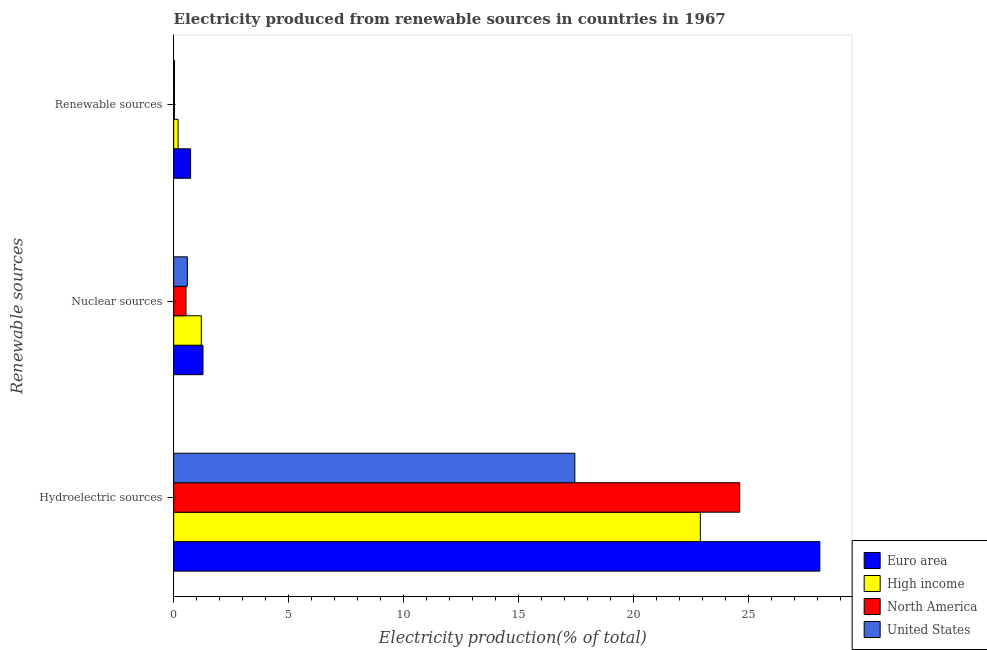How many different coloured bars are there?
Ensure brevity in your answer.  4. What is the label of the 1st group of bars from the top?
Keep it short and to the point. Renewable sources. What is the percentage of electricity produced by hydroelectric sources in High income?
Offer a terse response. 22.91. Across all countries, what is the maximum percentage of electricity produced by nuclear sources?
Provide a short and direct response. 1.27. Across all countries, what is the minimum percentage of electricity produced by hydroelectric sources?
Your answer should be compact. 17.45. In which country was the percentage of electricity produced by nuclear sources maximum?
Give a very brief answer. Euro area. In which country was the percentage of electricity produced by hydroelectric sources minimum?
Your answer should be compact. United States. What is the total percentage of electricity produced by hydroelectric sources in the graph?
Ensure brevity in your answer.  93.08. What is the difference between the percentage of electricity produced by renewable sources in Euro area and that in United States?
Your answer should be compact. 0.7. What is the difference between the percentage of electricity produced by nuclear sources in High income and the percentage of electricity produced by hydroelectric sources in North America?
Keep it short and to the point. -23.42. What is the average percentage of electricity produced by renewable sources per country?
Keep it short and to the point. 0.25. What is the difference between the percentage of electricity produced by hydroelectric sources and percentage of electricity produced by nuclear sources in North America?
Your response must be concise. 24.08. In how many countries, is the percentage of electricity produced by renewable sources greater than 1 %?
Provide a succinct answer. 0. What is the ratio of the percentage of electricity produced by renewable sources in High income to that in United States?
Provide a succinct answer. 5.17. Is the percentage of electricity produced by hydroelectric sources in United States less than that in High income?
Offer a very short reply. Yes. Is the difference between the percentage of electricity produced by renewable sources in North America and High income greater than the difference between the percentage of electricity produced by nuclear sources in North America and High income?
Ensure brevity in your answer.  Yes. What is the difference between the highest and the second highest percentage of electricity produced by nuclear sources?
Your answer should be very brief. 0.07. What is the difference between the highest and the lowest percentage of electricity produced by hydroelectric sources?
Your answer should be very brief. 10.66. In how many countries, is the percentage of electricity produced by nuclear sources greater than the average percentage of electricity produced by nuclear sources taken over all countries?
Give a very brief answer. 2. Is it the case that in every country, the sum of the percentage of electricity produced by hydroelectric sources and percentage of electricity produced by nuclear sources is greater than the percentage of electricity produced by renewable sources?
Your answer should be compact. Yes. How many bars are there?
Make the answer very short. 12. How many countries are there in the graph?
Offer a very short reply. 4. Are the values on the major ticks of X-axis written in scientific E-notation?
Provide a succinct answer. No. Does the graph contain any zero values?
Provide a short and direct response. No. How are the legend labels stacked?
Offer a very short reply. Vertical. What is the title of the graph?
Give a very brief answer. Electricity produced from renewable sources in countries in 1967. What is the label or title of the Y-axis?
Offer a terse response. Renewable sources. What is the Electricity production(% of total) of Euro area in Hydroelectric sources?
Your answer should be compact. 28.1. What is the Electricity production(% of total) in High income in Hydroelectric sources?
Your response must be concise. 22.91. What is the Electricity production(% of total) in North America in Hydroelectric sources?
Provide a succinct answer. 24.62. What is the Electricity production(% of total) in United States in Hydroelectric sources?
Offer a very short reply. 17.45. What is the Electricity production(% of total) in Euro area in Nuclear sources?
Your response must be concise. 1.27. What is the Electricity production(% of total) in High income in Nuclear sources?
Your answer should be compact. 1.2. What is the Electricity production(% of total) of North America in Nuclear sources?
Your response must be concise. 0.54. What is the Electricity production(% of total) of United States in Nuclear sources?
Your response must be concise. 0.59. What is the Electricity production(% of total) of Euro area in Renewable sources?
Your answer should be compact. 0.74. What is the Electricity production(% of total) in High income in Renewable sources?
Your response must be concise. 0.19. What is the Electricity production(% of total) in North America in Renewable sources?
Offer a very short reply. 0.03. What is the Electricity production(% of total) in United States in Renewable sources?
Provide a short and direct response. 0.04. Across all Renewable sources, what is the maximum Electricity production(% of total) in Euro area?
Provide a succinct answer. 28.1. Across all Renewable sources, what is the maximum Electricity production(% of total) of High income?
Provide a short and direct response. 22.91. Across all Renewable sources, what is the maximum Electricity production(% of total) in North America?
Your response must be concise. 24.62. Across all Renewable sources, what is the maximum Electricity production(% of total) of United States?
Give a very brief answer. 17.45. Across all Renewable sources, what is the minimum Electricity production(% of total) in Euro area?
Offer a very short reply. 0.74. Across all Renewable sources, what is the minimum Electricity production(% of total) of High income?
Give a very brief answer. 0.19. Across all Renewable sources, what is the minimum Electricity production(% of total) in North America?
Your answer should be very brief. 0.03. Across all Renewable sources, what is the minimum Electricity production(% of total) in United States?
Your answer should be very brief. 0.04. What is the total Electricity production(% of total) in Euro area in the graph?
Provide a short and direct response. 30.11. What is the total Electricity production(% of total) of High income in the graph?
Make the answer very short. 24.3. What is the total Electricity production(% of total) in North America in the graph?
Ensure brevity in your answer.  25.19. What is the total Electricity production(% of total) in United States in the graph?
Provide a succinct answer. 18.08. What is the difference between the Electricity production(% of total) of Euro area in Hydroelectric sources and that in Nuclear sources?
Make the answer very short. 26.83. What is the difference between the Electricity production(% of total) in High income in Hydroelectric sources and that in Nuclear sources?
Make the answer very short. 21.71. What is the difference between the Electricity production(% of total) in North America in Hydroelectric sources and that in Nuclear sources?
Provide a short and direct response. 24.08. What is the difference between the Electricity production(% of total) in United States in Hydroelectric sources and that in Nuclear sources?
Your answer should be compact. 16.85. What is the difference between the Electricity production(% of total) of Euro area in Hydroelectric sources and that in Renewable sources?
Keep it short and to the point. 27.37. What is the difference between the Electricity production(% of total) of High income in Hydroelectric sources and that in Renewable sources?
Give a very brief answer. 22.72. What is the difference between the Electricity production(% of total) in North America in Hydroelectric sources and that in Renewable sources?
Offer a terse response. 24.59. What is the difference between the Electricity production(% of total) of United States in Hydroelectric sources and that in Renewable sources?
Give a very brief answer. 17.41. What is the difference between the Electricity production(% of total) in Euro area in Nuclear sources and that in Renewable sources?
Provide a succinct answer. 0.54. What is the difference between the Electricity production(% of total) of High income in Nuclear sources and that in Renewable sources?
Offer a very short reply. 1.01. What is the difference between the Electricity production(% of total) in North America in Nuclear sources and that in Renewable sources?
Ensure brevity in your answer.  0.5. What is the difference between the Electricity production(% of total) of United States in Nuclear sources and that in Renewable sources?
Keep it short and to the point. 0.56. What is the difference between the Electricity production(% of total) of Euro area in Hydroelectric sources and the Electricity production(% of total) of High income in Nuclear sources?
Your answer should be very brief. 26.9. What is the difference between the Electricity production(% of total) in Euro area in Hydroelectric sources and the Electricity production(% of total) in North America in Nuclear sources?
Keep it short and to the point. 27.57. What is the difference between the Electricity production(% of total) in Euro area in Hydroelectric sources and the Electricity production(% of total) in United States in Nuclear sources?
Make the answer very short. 27.51. What is the difference between the Electricity production(% of total) of High income in Hydroelectric sources and the Electricity production(% of total) of North America in Nuclear sources?
Keep it short and to the point. 22.37. What is the difference between the Electricity production(% of total) in High income in Hydroelectric sources and the Electricity production(% of total) in United States in Nuclear sources?
Make the answer very short. 22.31. What is the difference between the Electricity production(% of total) in North America in Hydroelectric sources and the Electricity production(% of total) in United States in Nuclear sources?
Keep it short and to the point. 24.02. What is the difference between the Electricity production(% of total) of Euro area in Hydroelectric sources and the Electricity production(% of total) of High income in Renewable sources?
Your answer should be very brief. 27.91. What is the difference between the Electricity production(% of total) in Euro area in Hydroelectric sources and the Electricity production(% of total) in North America in Renewable sources?
Give a very brief answer. 28.07. What is the difference between the Electricity production(% of total) of Euro area in Hydroelectric sources and the Electricity production(% of total) of United States in Renewable sources?
Provide a short and direct response. 28.07. What is the difference between the Electricity production(% of total) in High income in Hydroelectric sources and the Electricity production(% of total) in North America in Renewable sources?
Keep it short and to the point. 22.87. What is the difference between the Electricity production(% of total) in High income in Hydroelectric sources and the Electricity production(% of total) in United States in Renewable sources?
Offer a terse response. 22.87. What is the difference between the Electricity production(% of total) of North America in Hydroelectric sources and the Electricity production(% of total) of United States in Renewable sources?
Provide a succinct answer. 24.58. What is the difference between the Electricity production(% of total) of Euro area in Nuclear sources and the Electricity production(% of total) of High income in Renewable sources?
Give a very brief answer. 1.08. What is the difference between the Electricity production(% of total) of Euro area in Nuclear sources and the Electricity production(% of total) of North America in Renewable sources?
Provide a succinct answer. 1.24. What is the difference between the Electricity production(% of total) in Euro area in Nuclear sources and the Electricity production(% of total) in United States in Renewable sources?
Give a very brief answer. 1.24. What is the difference between the Electricity production(% of total) of High income in Nuclear sources and the Electricity production(% of total) of North America in Renewable sources?
Make the answer very short. 1.17. What is the difference between the Electricity production(% of total) of High income in Nuclear sources and the Electricity production(% of total) of United States in Renewable sources?
Your answer should be very brief. 1.16. What is the difference between the Electricity production(% of total) in North America in Nuclear sources and the Electricity production(% of total) in United States in Renewable sources?
Offer a terse response. 0.5. What is the average Electricity production(% of total) of Euro area per Renewable sources?
Offer a very short reply. 10.04. What is the average Electricity production(% of total) in High income per Renewable sources?
Offer a terse response. 8.1. What is the average Electricity production(% of total) in North America per Renewable sources?
Give a very brief answer. 8.4. What is the average Electricity production(% of total) in United States per Renewable sources?
Ensure brevity in your answer.  6.03. What is the difference between the Electricity production(% of total) in Euro area and Electricity production(% of total) in High income in Hydroelectric sources?
Provide a succinct answer. 5.2. What is the difference between the Electricity production(% of total) of Euro area and Electricity production(% of total) of North America in Hydroelectric sources?
Offer a very short reply. 3.49. What is the difference between the Electricity production(% of total) in Euro area and Electricity production(% of total) in United States in Hydroelectric sources?
Make the answer very short. 10.66. What is the difference between the Electricity production(% of total) in High income and Electricity production(% of total) in North America in Hydroelectric sources?
Give a very brief answer. -1.71. What is the difference between the Electricity production(% of total) in High income and Electricity production(% of total) in United States in Hydroelectric sources?
Provide a succinct answer. 5.46. What is the difference between the Electricity production(% of total) of North America and Electricity production(% of total) of United States in Hydroelectric sources?
Your answer should be compact. 7.17. What is the difference between the Electricity production(% of total) of Euro area and Electricity production(% of total) of High income in Nuclear sources?
Your answer should be very brief. 0.07. What is the difference between the Electricity production(% of total) of Euro area and Electricity production(% of total) of North America in Nuclear sources?
Make the answer very short. 0.74. What is the difference between the Electricity production(% of total) of Euro area and Electricity production(% of total) of United States in Nuclear sources?
Make the answer very short. 0.68. What is the difference between the Electricity production(% of total) of High income and Electricity production(% of total) of North America in Nuclear sources?
Offer a terse response. 0.67. What is the difference between the Electricity production(% of total) of High income and Electricity production(% of total) of United States in Nuclear sources?
Offer a terse response. 0.61. What is the difference between the Electricity production(% of total) of North America and Electricity production(% of total) of United States in Nuclear sources?
Offer a very short reply. -0.06. What is the difference between the Electricity production(% of total) of Euro area and Electricity production(% of total) of High income in Renewable sources?
Keep it short and to the point. 0.55. What is the difference between the Electricity production(% of total) of Euro area and Electricity production(% of total) of North America in Renewable sources?
Offer a terse response. 0.7. What is the difference between the Electricity production(% of total) of Euro area and Electricity production(% of total) of United States in Renewable sources?
Your answer should be very brief. 0.7. What is the difference between the Electricity production(% of total) in High income and Electricity production(% of total) in North America in Renewable sources?
Make the answer very short. 0.16. What is the difference between the Electricity production(% of total) in High income and Electricity production(% of total) in United States in Renewable sources?
Provide a succinct answer. 0.15. What is the difference between the Electricity production(% of total) in North America and Electricity production(% of total) in United States in Renewable sources?
Offer a very short reply. -0. What is the ratio of the Electricity production(% of total) in Euro area in Hydroelectric sources to that in Nuclear sources?
Your response must be concise. 22.05. What is the ratio of the Electricity production(% of total) in High income in Hydroelectric sources to that in Nuclear sources?
Provide a short and direct response. 19.07. What is the ratio of the Electricity production(% of total) in North America in Hydroelectric sources to that in Nuclear sources?
Ensure brevity in your answer.  45.92. What is the ratio of the Electricity production(% of total) in United States in Hydroelectric sources to that in Nuclear sources?
Keep it short and to the point. 29.33. What is the ratio of the Electricity production(% of total) of Euro area in Hydroelectric sources to that in Renewable sources?
Offer a terse response. 38.15. What is the ratio of the Electricity production(% of total) of High income in Hydroelectric sources to that in Renewable sources?
Offer a terse response. 120.03. What is the ratio of the Electricity production(% of total) of North America in Hydroelectric sources to that in Renewable sources?
Provide a succinct answer. 755.58. What is the ratio of the Electricity production(% of total) in United States in Hydroelectric sources to that in Renewable sources?
Keep it short and to the point. 473.04. What is the ratio of the Electricity production(% of total) of Euro area in Nuclear sources to that in Renewable sources?
Offer a very short reply. 1.73. What is the ratio of the Electricity production(% of total) in High income in Nuclear sources to that in Renewable sources?
Offer a terse response. 6.3. What is the ratio of the Electricity production(% of total) of North America in Nuclear sources to that in Renewable sources?
Your answer should be very brief. 16.45. What is the ratio of the Electricity production(% of total) of United States in Nuclear sources to that in Renewable sources?
Give a very brief answer. 16.13. What is the difference between the highest and the second highest Electricity production(% of total) of Euro area?
Make the answer very short. 26.83. What is the difference between the highest and the second highest Electricity production(% of total) of High income?
Your answer should be very brief. 21.71. What is the difference between the highest and the second highest Electricity production(% of total) of North America?
Give a very brief answer. 24.08. What is the difference between the highest and the second highest Electricity production(% of total) of United States?
Give a very brief answer. 16.85. What is the difference between the highest and the lowest Electricity production(% of total) in Euro area?
Your response must be concise. 27.37. What is the difference between the highest and the lowest Electricity production(% of total) of High income?
Give a very brief answer. 22.72. What is the difference between the highest and the lowest Electricity production(% of total) in North America?
Your response must be concise. 24.59. What is the difference between the highest and the lowest Electricity production(% of total) in United States?
Give a very brief answer. 17.41. 